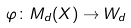<formula> <loc_0><loc_0><loc_500><loc_500>\varphi \colon M _ { d } ( X ) \rightarrow W _ { d }</formula> 